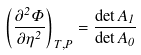Convert formula to latex. <formula><loc_0><loc_0><loc_500><loc_500>\left ( \frac { \partial ^ { 2 } \Phi } { \partial \eta ^ { 2 } } \right ) _ { T , P } = \frac { \det A _ { 1 } } { \det A _ { 0 } }</formula> 